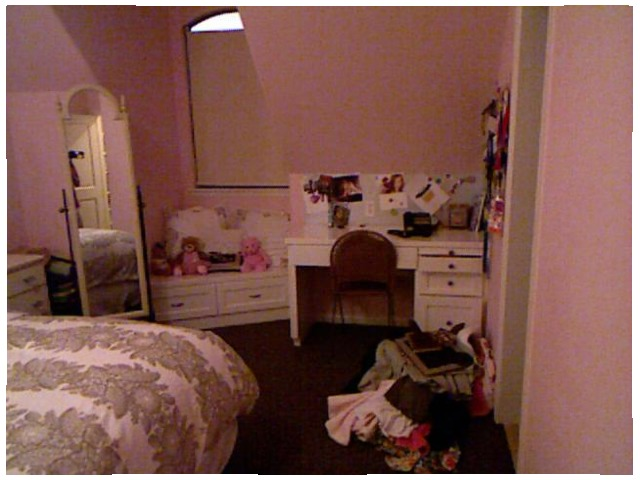<image>
Is there a teddy bear in front of the teddy bear? No. The teddy bear is not in front of the teddy bear. The spatial positioning shows a different relationship between these objects. Is there a mirror on the bed? No. The mirror is not positioned on the bed. They may be near each other, but the mirror is not supported by or resting on top of the bed. Is the teddy bear on the bed? No. The teddy bear is not positioned on the bed. They may be near each other, but the teddy bear is not supported by or resting on top of the bed. Is there a wall behind the table? Yes. From this viewpoint, the wall is positioned behind the table, with the table partially or fully occluding the wall. Is there a chair behind the desk? No. The chair is not behind the desk. From this viewpoint, the chair appears to be positioned elsewhere in the scene. 